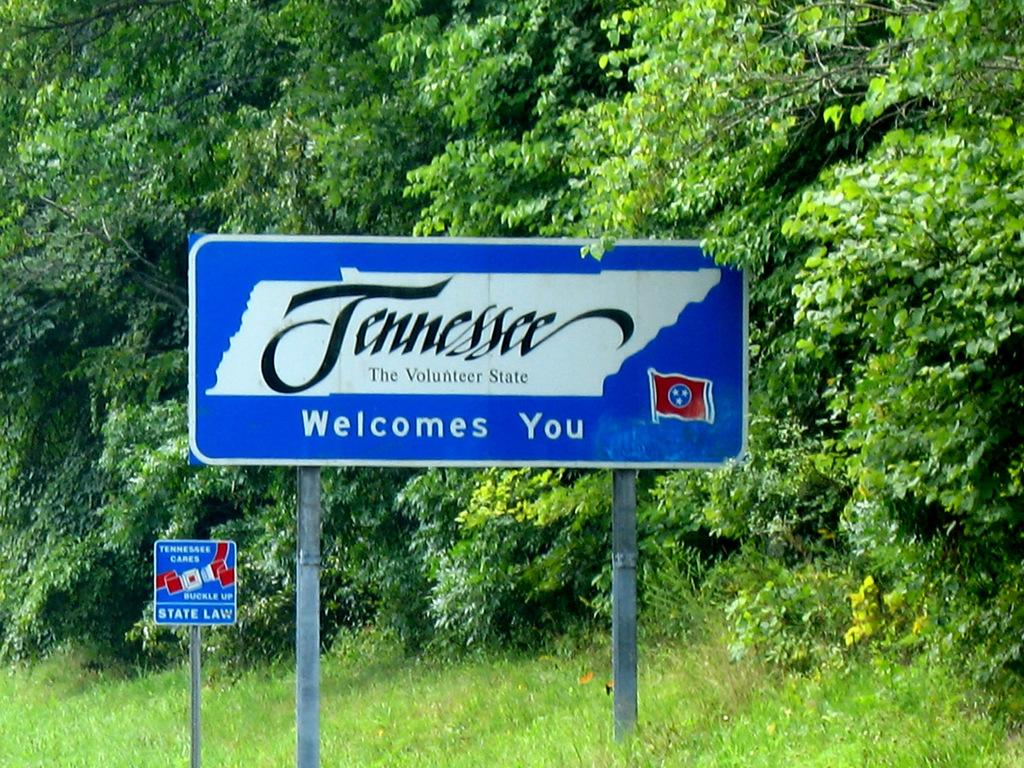What can be seen on the sign boards in the image? There are sign boards with text in the image. What type of vegetation is visible in the image? There is grass visible in the image. What else can be seen in the image besides the sign boards and grass? There is a group of trees in the image. How many chickens are present in the image? There are no chickens present in the image. What type of celebration is taking place in the image? There is no indication of a celebration or birthday in the image. 